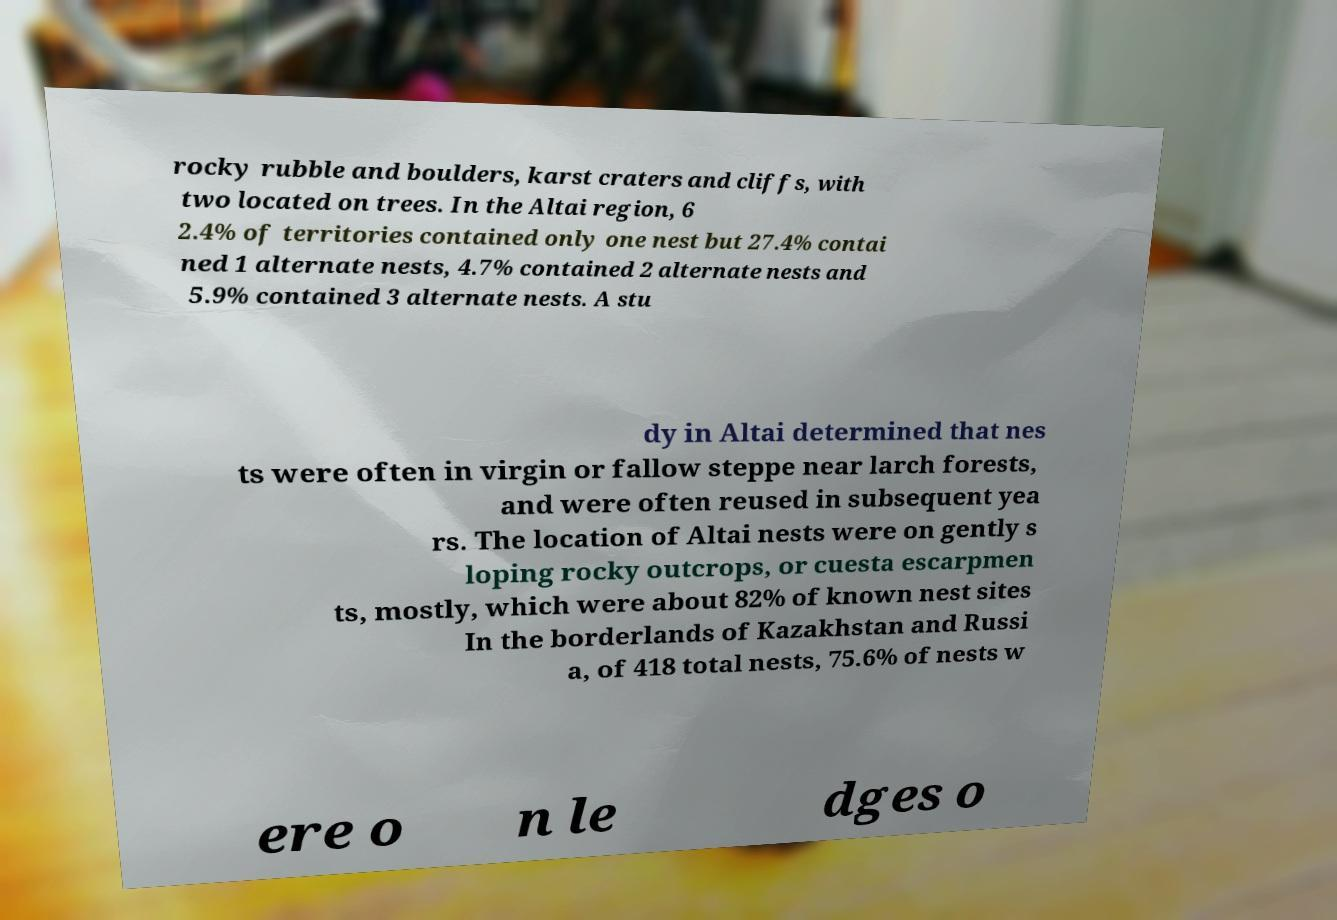I need the written content from this picture converted into text. Can you do that? rocky rubble and boulders, karst craters and cliffs, with two located on trees. In the Altai region, 6 2.4% of territories contained only one nest but 27.4% contai ned 1 alternate nests, 4.7% contained 2 alternate nests and 5.9% contained 3 alternate nests. A stu dy in Altai determined that nes ts were often in virgin or fallow steppe near larch forests, and were often reused in subsequent yea rs. The location of Altai nests were on gently s loping rocky outcrops, or cuesta escarpmen ts, mostly, which were about 82% of known nest sites In the borderlands of Kazakhstan and Russi a, of 418 total nests, 75.6% of nests w ere o n le dges o 